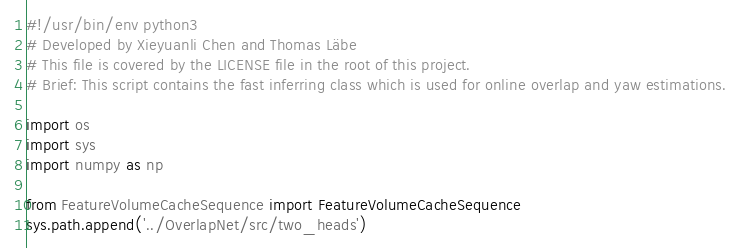<code> <loc_0><loc_0><loc_500><loc_500><_Python_>#!/usr/bin/env python3
# Developed by Xieyuanli Chen and Thomas Läbe
# This file is covered by the LICENSE file in the root of this project.
# Brief: This script contains the fast inferring class which is used for online overlap and yaw estimations.

import os
import sys
import numpy as np

from FeatureVolumeCacheSequence import FeatureVolumeCacheSequence
sys.path.append('../OverlapNet/src/two_heads')</code> 